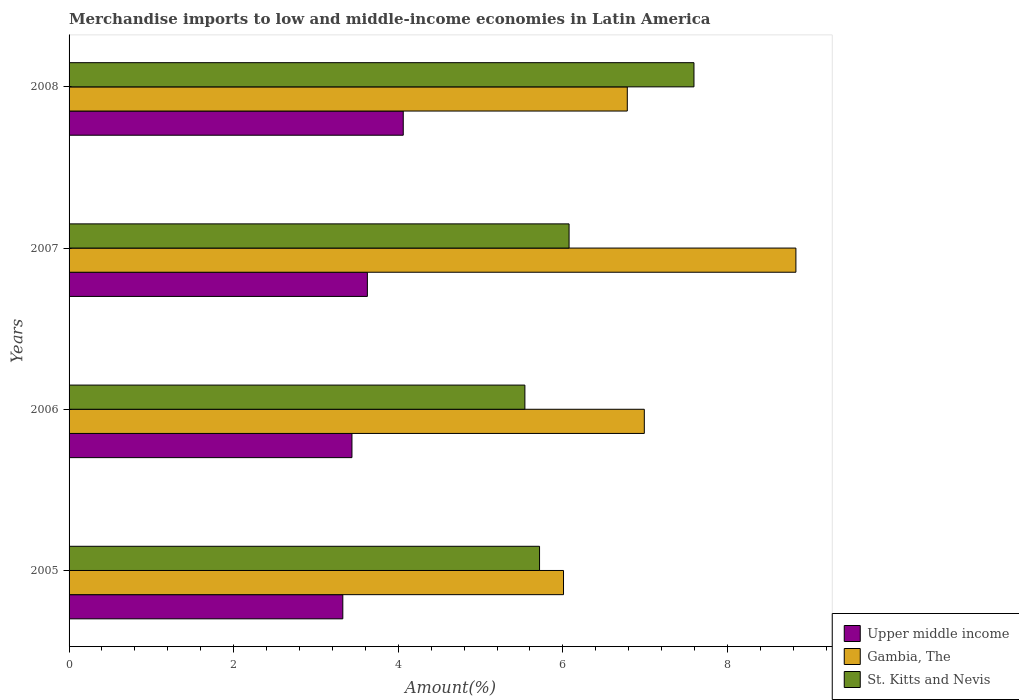How many groups of bars are there?
Your answer should be compact. 4. How many bars are there on the 1st tick from the bottom?
Provide a short and direct response. 3. What is the percentage of amount earned from merchandise imports in St. Kitts and Nevis in 2006?
Provide a short and direct response. 5.54. Across all years, what is the maximum percentage of amount earned from merchandise imports in Gambia, The?
Provide a succinct answer. 8.83. Across all years, what is the minimum percentage of amount earned from merchandise imports in St. Kitts and Nevis?
Your answer should be compact. 5.54. What is the total percentage of amount earned from merchandise imports in St. Kitts and Nevis in the graph?
Offer a terse response. 24.92. What is the difference between the percentage of amount earned from merchandise imports in St. Kitts and Nevis in 2005 and that in 2007?
Your answer should be very brief. -0.36. What is the difference between the percentage of amount earned from merchandise imports in St. Kitts and Nevis in 2005 and the percentage of amount earned from merchandise imports in Gambia, The in 2008?
Keep it short and to the point. -1.07. What is the average percentage of amount earned from merchandise imports in St. Kitts and Nevis per year?
Make the answer very short. 6.23. In the year 2007, what is the difference between the percentage of amount earned from merchandise imports in Gambia, The and percentage of amount earned from merchandise imports in Upper middle income?
Keep it short and to the point. 5.21. What is the ratio of the percentage of amount earned from merchandise imports in Upper middle income in 2007 to that in 2008?
Provide a succinct answer. 0.89. Is the difference between the percentage of amount earned from merchandise imports in Gambia, The in 2006 and 2008 greater than the difference between the percentage of amount earned from merchandise imports in Upper middle income in 2006 and 2008?
Ensure brevity in your answer.  Yes. What is the difference between the highest and the second highest percentage of amount earned from merchandise imports in Upper middle income?
Provide a short and direct response. 0.44. What is the difference between the highest and the lowest percentage of amount earned from merchandise imports in Upper middle income?
Ensure brevity in your answer.  0.73. In how many years, is the percentage of amount earned from merchandise imports in St. Kitts and Nevis greater than the average percentage of amount earned from merchandise imports in St. Kitts and Nevis taken over all years?
Ensure brevity in your answer.  1. Is the sum of the percentage of amount earned from merchandise imports in St. Kitts and Nevis in 2005 and 2008 greater than the maximum percentage of amount earned from merchandise imports in Upper middle income across all years?
Offer a very short reply. Yes. What does the 2nd bar from the top in 2006 represents?
Your answer should be compact. Gambia, The. What does the 2nd bar from the bottom in 2005 represents?
Make the answer very short. Gambia, The. Are all the bars in the graph horizontal?
Your answer should be very brief. Yes. What is the difference between two consecutive major ticks on the X-axis?
Offer a very short reply. 2. Are the values on the major ticks of X-axis written in scientific E-notation?
Ensure brevity in your answer.  No. Does the graph contain any zero values?
Offer a very short reply. No. Where does the legend appear in the graph?
Keep it short and to the point. Bottom right. How are the legend labels stacked?
Provide a short and direct response. Vertical. What is the title of the graph?
Your answer should be very brief. Merchandise imports to low and middle-income economies in Latin America. What is the label or title of the X-axis?
Your answer should be very brief. Amount(%). What is the label or title of the Y-axis?
Offer a terse response. Years. What is the Amount(%) in Upper middle income in 2005?
Your answer should be very brief. 3.33. What is the Amount(%) of Gambia, The in 2005?
Provide a succinct answer. 6.01. What is the Amount(%) in St. Kitts and Nevis in 2005?
Make the answer very short. 5.72. What is the Amount(%) of Upper middle income in 2006?
Offer a terse response. 3.44. What is the Amount(%) of Gambia, The in 2006?
Keep it short and to the point. 6.99. What is the Amount(%) of St. Kitts and Nevis in 2006?
Your answer should be compact. 5.54. What is the Amount(%) in Upper middle income in 2007?
Give a very brief answer. 3.62. What is the Amount(%) in Gambia, The in 2007?
Your response must be concise. 8.83. What is the Amount(%) in St. Kitts and Nevis in 2007?
Make the answer very short. 6.08. What is the Amount(%) in Upper middle income in 2008?
Keep it short and to the point. 4.06. What is the Amount(%) in Gambia, The in 2008?
Keep it short and to the point. 6.78. What is the Amount(%) of St. Kitts and Nevis in 2008?
Provide a short and direct response. 7.59. Across all years, what is the maximum Amount(%) of Upper middle income?
Offer a very short reply. 4.06. Across all years, what is the maximum Amount(%) in Gambia, The?
Provide a short and direct response. 8.83. Across all years, what is the maximum Amount(%) of St. Kitts and Nevis?
Offer a very short reply. 7.59. Across all years, what is the minimum Amount(%) in Upper middle income?
Keep it short and to the point. 3.33. Across all years, what is the minimum Amount(%) in Gambia, The?
Your response must be concise. 6.01. Across all years, what is the minimum Amount(%) in St. Kitts and Nevis?
Your response must be concise. 5.54. What is the total Amount(%) of Upper middle income in the graph?
Make the answer very short. 14.45. What is the total Amount(%) in Gambia, The in the graph?
Your answer should be compact. 28.61. What is the total Amount(%) in St. Kitts and Nevis in the graph?
Your answer should be very brief. 24.92. What is the difference between the Amount(%) in Upper middle income in 2005 and that in 2006?
Keep it short and to the point. -0.11. What is the difference between the Amount(%) of Gambia, The in 2005 and that in 2006?
Ensure brevity in your answer.  -0.98. What is the difference between the Amount(%) of St. Kitts and Nevis in 2005 and that in 2006?
Ensure brevity in your answer.  0.18. What is the difference between the Amount(%) in Upper middle income in 2005 and that in 2007?
Your answer should be compact. -0.3. What is the difference between the Amount(%) of Gambia, The in 2005 and that in 2007?
Provide a short and direct response. -2.82. What is the difference between the Amount(%) in St. Kitts and Nevis in 2005 and that in 2007?
Make the answer very short. -0.36. What is the difference between the Amount(%) of Upper middle income in 2005 and that in 2008?
Your answer should be compact. -0.73. What is the difference between the Amount(%) in Gambia, The in 2005 and that in 2008?
Your answer should be very brief. -0.78. What is the difference between the Amount(%) of St. Kitts and Nevis in 2005 and that in 2008?
Offer a very short reply. -1.88. What is the difference between the Amount(%) in Upper middle income in 2006 and that in 2007?
Your response must be concise. -0.19. What is the difference between the Amount(%) of Gambia, The in 2006 and that in 2007?
Keep it short and to the point. -1.84. What is the difference between the Amount(%) in St. Kitts and Nevis in 2006 and that in 2007?
Your response must be concise. -0.54. What is the difference between the Amount(%) of Upper middle income in 2006 and that in 2008?
Provide a short and direct response. -0.62. What is the difference between the Amount(%) of Gambia, The in 2006 and that in 2008?
Offer a very short reply. 0.21. What is the difference between the Amount(%) in St. Kitts and Nevis in 2006 and that in 2008?
Your answer should be compact. -2.05. What is the difference between the Amount(%) of Upper middle income in 2007 and that in 2008?
Ensure brevity in your answer.  -0.44. What is the difference between the Amount(%) of Gambia, The in 2007 and that in 2008?
Your response must be concise. 2.05. What is the difference between the Amount(%) in St. Kitts and Nevis in 2007 and that in 2008?
Keep it short and to the point. -1.52. What is the difference between the Amount(%) of Upper middle income in 2005 and the Amount(%) of Gambia, The in 2006?
Your answer should be very brief. -3.66. What is the difference between the Amount(%) of Upper middle income in 2005 and the Amount(%) of St. Kitts and Nevis in 2006?
Your response must be concise. -2.21. What is the difference between the Amount(%) of Gambia, The in 2005 and the Amount(%) of St. Kitts and Nevis in 2006?
Ensure brevity in your answer.  0.47. What is the difference between the Amount(%) of Upper middle income in 2005 and the Amount(%) of Gambia, The in 2007?
Give a very brief answer. -5.51. What is the difference between the Amount(%) of Upper middle income in 2005 and the Amount(%) of St. Kitts and Nevis in 2007?
Offer a terse response. -2.75. What is the difference between the Amount(%) in Gambia, The in 2005 and the Amount(%) in St. Kitts and Nevis in 2007?
Ensure brevity in your answer.  -0.07. What is the difference between the Amount(%) of Upper middle income in 2005 and the Amount(%) of Gambia, The in 2008?
Make the answer very short. -3.46. What is the difference between the Amount(%) in Upper middle income in 2005 and the Amount(%) in St. Kitts and Nevis in 2008?
Your answer should be compact. -4.27. What is the difference between the Amount(%) in Gambia, The in 2005 and the Amount(%) in St. Kitts and Nevis in 2008?
Offer a terse response. -1.59. What is the difference between the Amount(%) in Upper middle income in 2006 and the Amount(%) in Gambia, The in 2007?
Give a very brief answer. -5.39. What is the difference between the Amount(%) of Upper middle income in 2006 and the Amount(%) of St. Kitts and Nevis in 2007?
Provide a short and direct response. -2.64. What is the difference between the Amount(%) in Gambia, The in 2006 and the Amount(%) in St. Kitts and Nevis in 2007?
Make the answer very short. 0.91. What is the difference between the Amount(%) in Upper middle income in 2006 and the Amount(%) in Gambia, The in 2008?
Offer a very short reply. -3.35. What is the difference between the Amount(%) of Upper middle income in 2006 and the Amount(%) of St. Kitts and Nevis in 2008?
Offer a very short reply. -4.16. What is the difference between the Amount(%) in Gambia, The in 2006 and the Amount(%) in St. Kitts and Nevis in 2008?
Ensure brevity in your answer.  -0.6. What is the difference between the Amount(%) of Upper middle income in 2007 and the Amount(%) of Gambia, The in 2008?
Offer a terse response. -3.16. What is the difference between the Amount(%) of Upper middle income in 2007 and the Amount(%) of St. Kitts and Nevis in 2008?
Make the answer very short. -3.97. What is the difference between the Amount(%) of Gambia, The in 2007 and the Amount(%) of St. Kitts and Nevis in 2008?
Your response must be concise. 1.24. What is the average Amount(%) of Upper middle income per year?
Offer a terse response. 3.61. What is the average Amount(%) in Gambia, The per year?
Provide a short and direct response. 7.15. What is the average Amount(%) in St. Kitts and Nevis per year?
Your answer should be compact. 6.23. In the year 2005, what is the difference between the Amount(%) of Upper middle income and Amount(%) of Gambia, The?
Your answer should be very brief. -2.68. In the year 2005, what is the difference between the Amount(%) in Upper middle income and Amount(%) in St. Kitts and Nevis?
Keep it short and to the point. -2.39. In the year 2005, what is the difference between the Amount(%) of Gambia, The and Amount(%) of St. Kitts and Nevis?
Ensure brevity in your answer.  0.29. In the year 2006, what is the difference between the Amount(%) of Upper middle income and Amount(%) of Gambia, The?
Your response must be concise. -3.55. In the year 2006, what is the difference between the Amount(%) in Upper middle income and Amount(%) in St. Kitts and Nevis?
Your answer should be very brief. -2.1. In the year 2006, what is the difference between the Amount(%) in Gambia, The and Amount(%) in St. Kitts and Nevis?
Your answer should be compact. 1.45. In the year 2007, what is the difference between the Amount(%) of Upper middle income and Amount(%) of Gambia, The?
Make the answer very short. -5.21. In the year 2007, what is the difference between the Amount(%) of Upper middle income and Amount(%) of St. Kitts and Nevis?
Ensure brevity in your answer.  -2.45. In the year 2007, what is the difference between the Amount(%) in Gambia, The and Amount(%) in St. Kitts and Nevis?
Make the answer very short. 2.76. In the year 2008, what is the difference between the Amount(%) of Upper middle income and Amount(%) of Gambia, The?
Provide a short and direct response. -2.72. In the year 2008, what is the difference between the Amount(%) of Upper middle income and Amount(%) of St. Kitts and Nevis?
Offer a very short reply. -3.53. In the year 2008, what is the difference between the Amount(%) in Gambia, The and Amount(%) in St. Kitts and Nevis?
Keep it short and to the point. -0.81. What is the ratio of the Amount(%) of Gambia, The in 2005 to that in 2006?
Ensure brevity in your answer.  0.86. What is the ratio of the Amount(%) of St. Kitts and Nevis in 2005 to that in 2006?
Offer a terse response. 1.03. What is the ratio of the Amount(%) in Upper middle income in 2005 to that in 2007?
Your answer should be very brief. 0.92. What is the ratio of the Amount(%) of Gambia, The in 2005 to that in 2007?
Provide a succinct answer. 0.68. What is the ratio of the Amount(%) in St. Kitts and Nevis in 2005 to that in 2007?
Provide a short and direct response. 0.94. What is the ratio of the Amount(%) of Upper middle income in 2005 to that in 2008?
Your response must be concise. 0.82. What is the ratio of the Amount(%) in Gambia, The in 2005 to that in 2008?
Offer a terse response. 0.89. What is the ratio of the Amount(%) in St. Kitts and Nevis in 2005 to that in 2008?
Your answer should be compact. 0.75. What is the ratio of the Amount(%) in Upper middle income in 2006 to that in 2007?
Your answer should be compact. 0.95. What is the ratio of the Amount(%) of Gambia, The in 2006 to that in 2007?
Provide a succinct answer. 0.79. What is the ratio of the Amount(%) of St. Kitts and Nevis in 2006 to that in 2007?
Ensure brevity in your answer.  0.91. What is the ratio of the Amount(%) of Upper middle income in 2006 to that in 2008?
Give a very brief answer. 0.85. What is the ratio of the Amount(%) of Gambia, The in 2006 to that in 2008?
Provide a succinct answer. 1.03. What is the ratio of the Amount(%) in St. Kitts and Nevis in 2006 to that in 2008?
Provide a short and direct response. 0.73. What is the ratio of the Amount(%) in Upper middle income in 2007 to that in 2008?
Keep it short and to the point. 0.89. What is the ratio of the Amount(%) of Gambia, The in 2007 to that in 2008?
Offer a terse response. 1.3. What is the ratio of the Amount(%) of St. Kitts and Nevis in 2007 to that in 2008?
Keep it short and to the point. 0.8. What is the difference between the highest and the second highest Amount(%) in Upper middle income?
Ensure brevity in your answer.  0.44. What is the difference between the highest and the second highest Amount(%) in Gambia, The?
Provide a succinct answer. 1.84. What is the difference between the highest and the second highest Amount(%) in St. Kitts and Nevis?
Provide a succinct answer. 1.52. What is the difference between the highest and the lowest Amount(%) in Upper middle income?
Your answer should be very brief. 0.73. What is the difference between the highest and the lowest Amount(%) of Gambia, The?
Your response must be concise. 2.82. What is the difference between the highest and the lowest Amount(%) in St. Kitts and Nevis?
Provide a succinct answer. 2.05. 